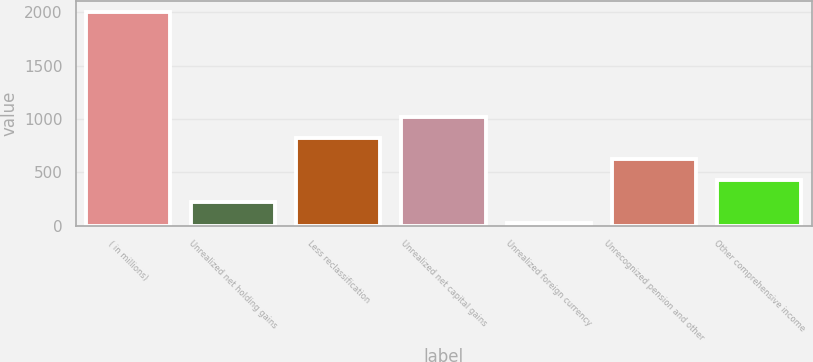Convert chart to OTSL. <chart><loc_0><loc_0><loc_500><loc_500><bar_chart><fcel>( in millions)<fcel>Unrealized net holding gains<fcel>Less reclassification<fcel>Unrealized net capital gains<fcel>Unrealized foreign currency<fcel>Unrecognized pension and other<fcel>Other comprehensive income<nl><fcel>2007<fcel>226.8<fcel>820.2<fcel>1018<fcel>29<fcel>622.4<fcel>424.6<nl></chart> 